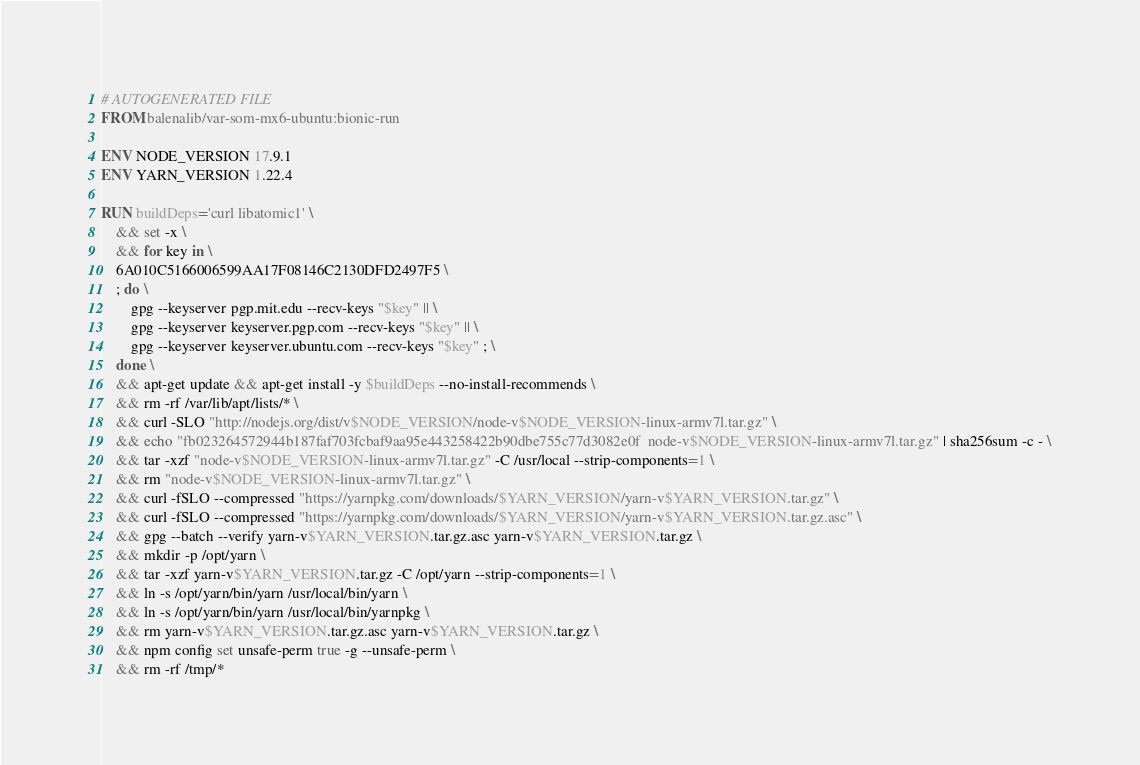<code> <loc_0><loc_0><loc_500><loc_500><_Dockerfile_># AUTOGENERATED FILE
FROM balenalib/var-som-mx6-ubuntu:bionic-run

ENV NODE_VERSION 17.9.1
ENV YARN_VERSION 1.22.4

RUN buildDeps='curl libatomic1' \
	&& set -x \
	&& for key in \
	6A010C5166006599AA17F08146C2130DFD2497F5 \
	; do \
		gpg --keyserver pgp.mit.edu --recv-keys "$key" || \
		gpg --keyserver keyserver.pgp.com --recv-keys "$key" || \
		gpg --keyserver keyserver.ubuntu.com --recv-keys "$key" ; \
	done \
	&& apt-get update && apt-get install -y $buildDeps --no-install-recommends \
	&& rm -rf /var/lib/apt/lists/* \
	&& curl -SLO "http://nodejs.org/dist/v$NODE_VERSION/node-v$NODE_VERSION-linux-armv7l.tar.gz" \
	&& echo "fb023264572944b187faf703fcbaf9aa95e443258422b90dbe755c77d3082e0f  node-v$NODE_VERSION-linux-armv7l.tar.gz" | sha256sum -c - \
	&& tar -xzf "node-v$NODE_VERSION-linux-armv7l.tar.gz" -C /usr/local --strip-components=1 \
	&& rm "node-v$NODE_VERSION-linux-armv7l.tar.gz" \
	&& curl -fSLO --compressed "https://yarnpkg.com/downloads/$YARN_VERSION/yarn-v$YARN_VERSION.tar.gz" \
	&& curl -fSLO --compressed "https://yarnpkg.com/downloads/$YARN_VERSION/yarn-v$YARN_VERSION.tar.gz.asc" \
	&& gpg --batch --verify yarn-v$YARN_VERSION.tar.gz.asc yarn-v$YARN_VERSION.tar.gz \
	&& mkdir -p /opt/yarn \
	&& tar -xzf yarn-v$YARN_VERSION.tar.gz -C /opt/yarn --strip-components=1 \
	&& ln -s /opt/yarn/bin/yarn /usr/local/bin/yarn \
	&& ln -s /opt/yarn/bin/yarn /usr/local/bin/yarnpkg \
	&& rm yarn-v$YARN_VERSION.tar.gz.asc yarn-v$YARN_VERSION.tar.gz \
	&& npm config set unsafe-perm true -g --unsafe-perm \
	&& rm -rf /tmp/*
</code> 